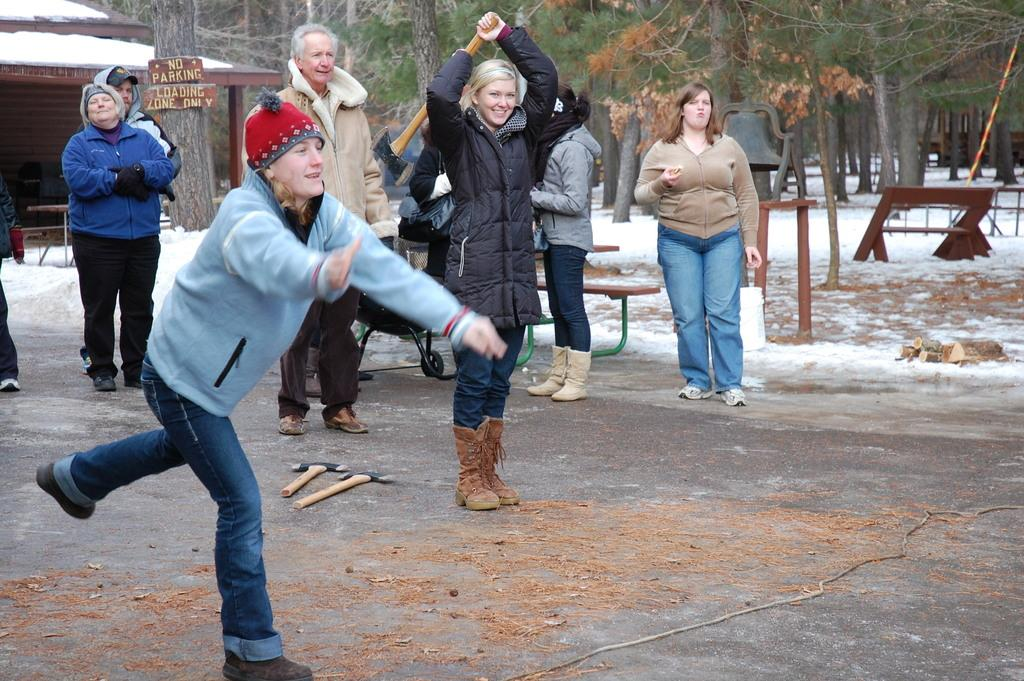What are the people in the image doing? The persons standing on the ground in the image are not performing any specific action, but one of them is holding an axe in her hands. What can be seen in the background of the image? In the background of the image, there are sign boards, stores, snow, trees, and benches. What might the person holding the axe be planning to do? It is not clear from the image what the person holding the axe intends to do with it. What type of linen is draped over the benches in the image? There is no linen draped over the benches in the image. What is the current hour depicted in the image? The image does not show any indication of the time or hour. 